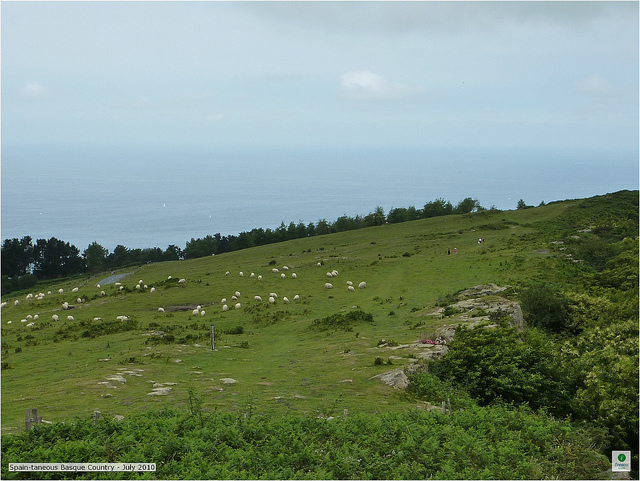Please extract the text content from this image. Spain taneous Bssque Country July 2010 